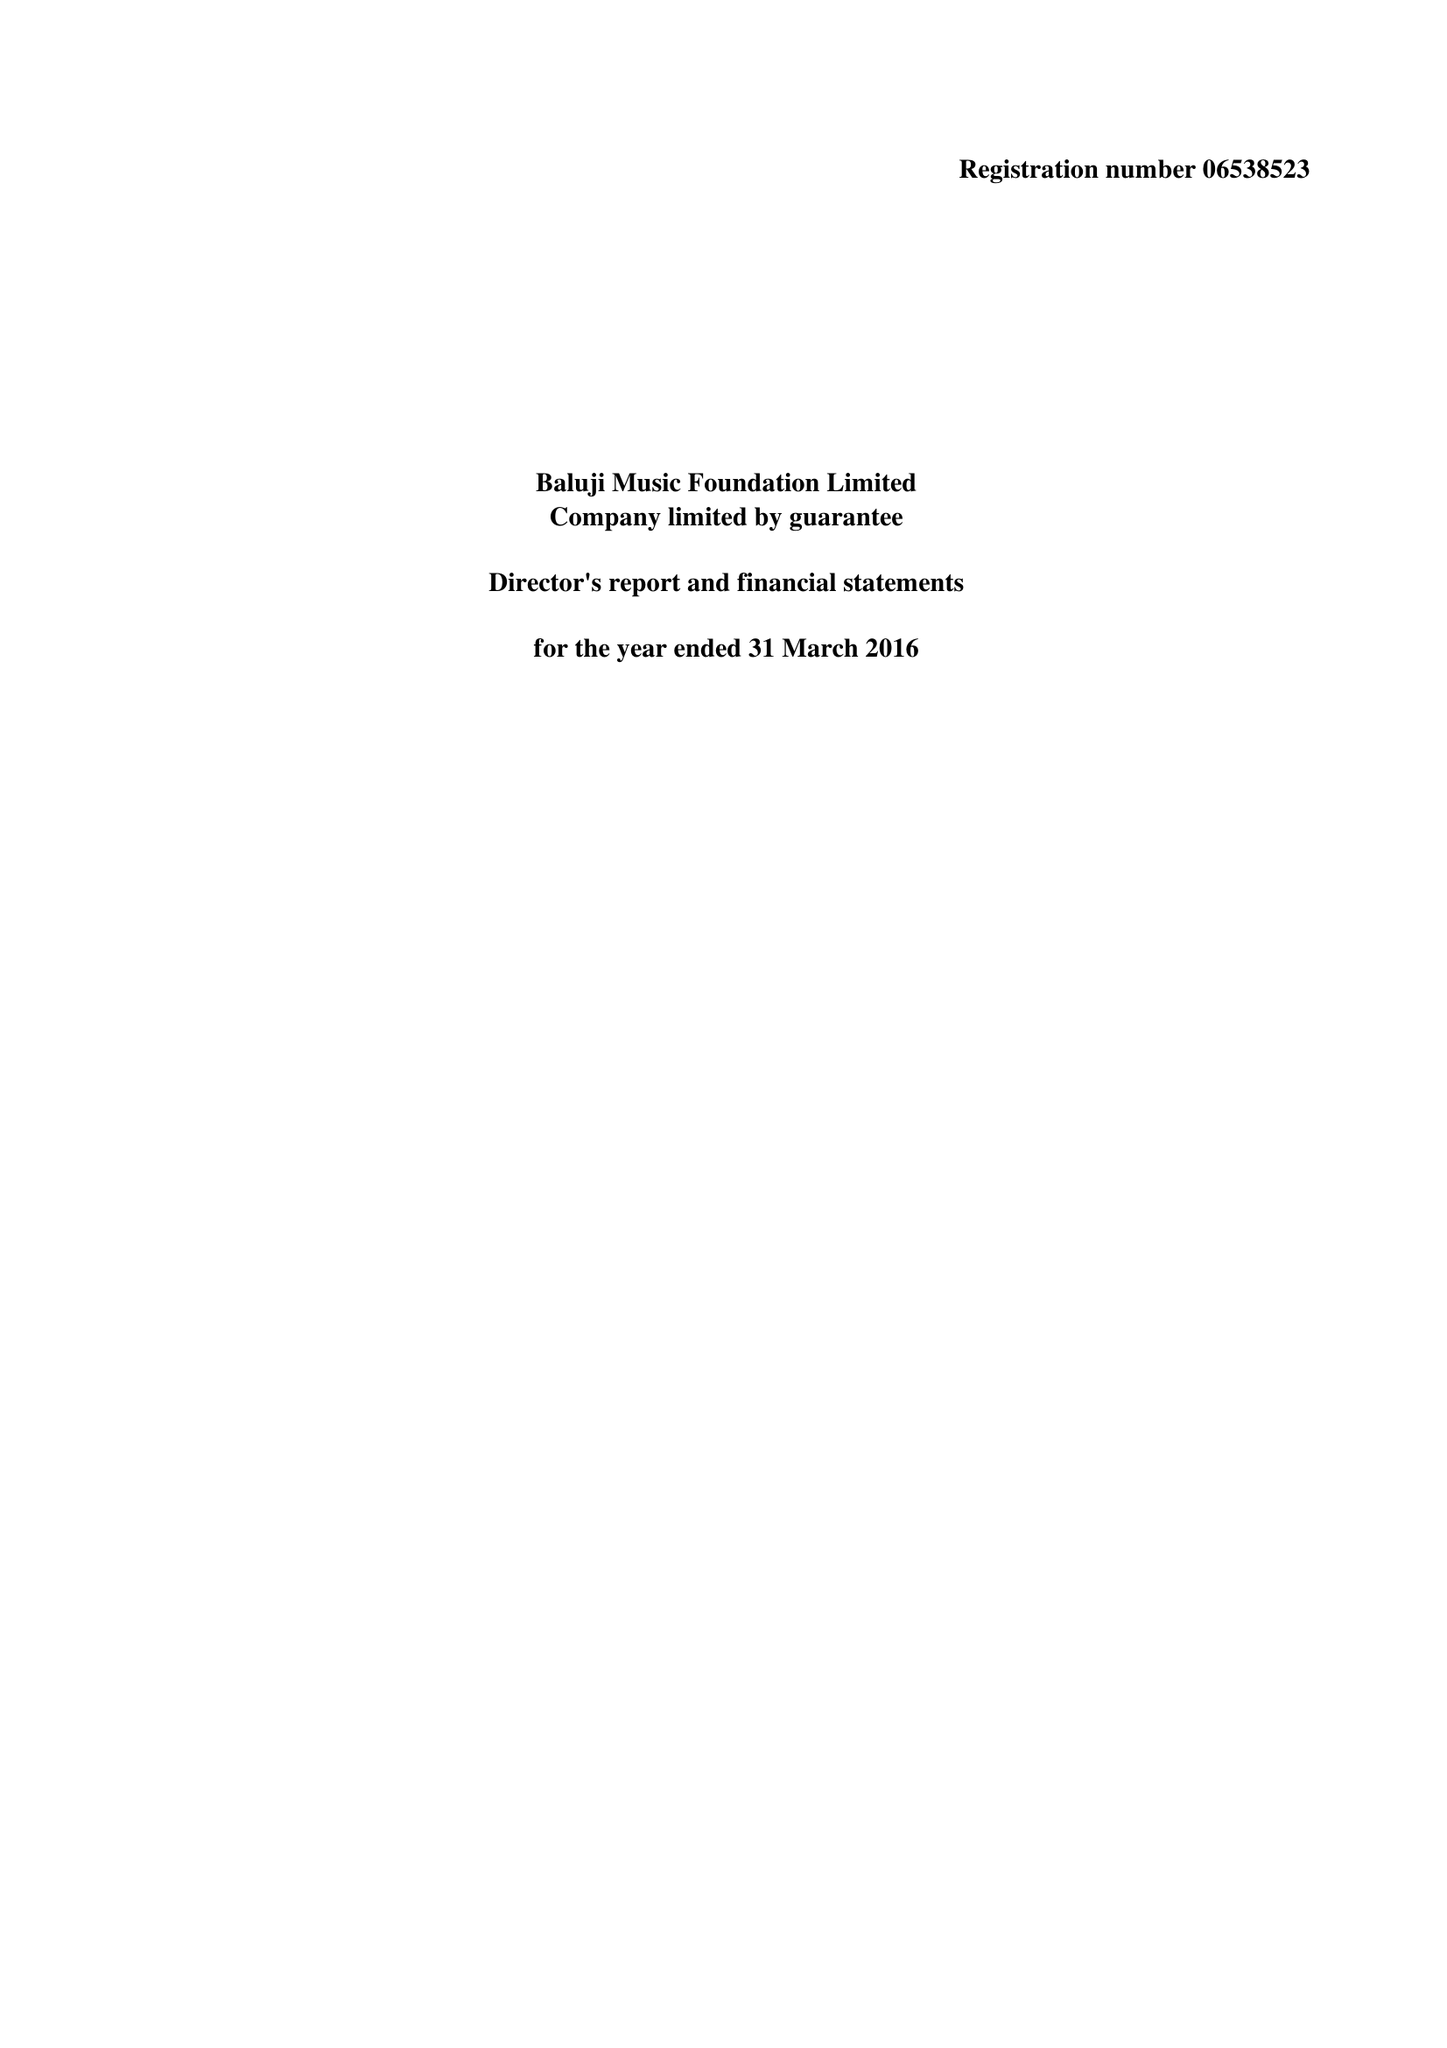What is the value for the income_annually_in_british_pounds?
Answer the question using a single word or phrase. 26314.00 